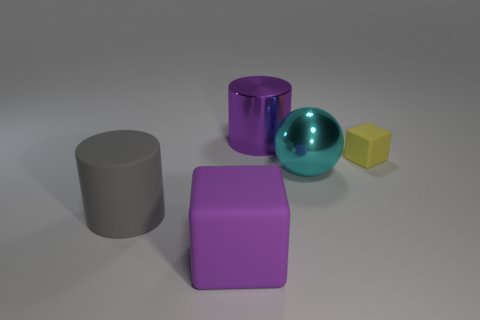Add 1 tiny green matte balls. How many objects exist? 6 Subtract all purple cylinders. How many cylinders are left? 1 Subtract 0 gray balls. How many objects are left? 5 Subtract all cubes. How many objects are left? 3 Subtract 1 cubes. How many cubes are left? 1 Subtract all red spheres. Subtract all cyan cylinders. How many spheres are left? 1 Subtract all blue blocks. Subtract all purple matte things. How many objects are left? 4 Add 5 purple matte things. How many purple matte things are left? 6 Add 4 purple cylinders. How many purple cylinders exist? 5 